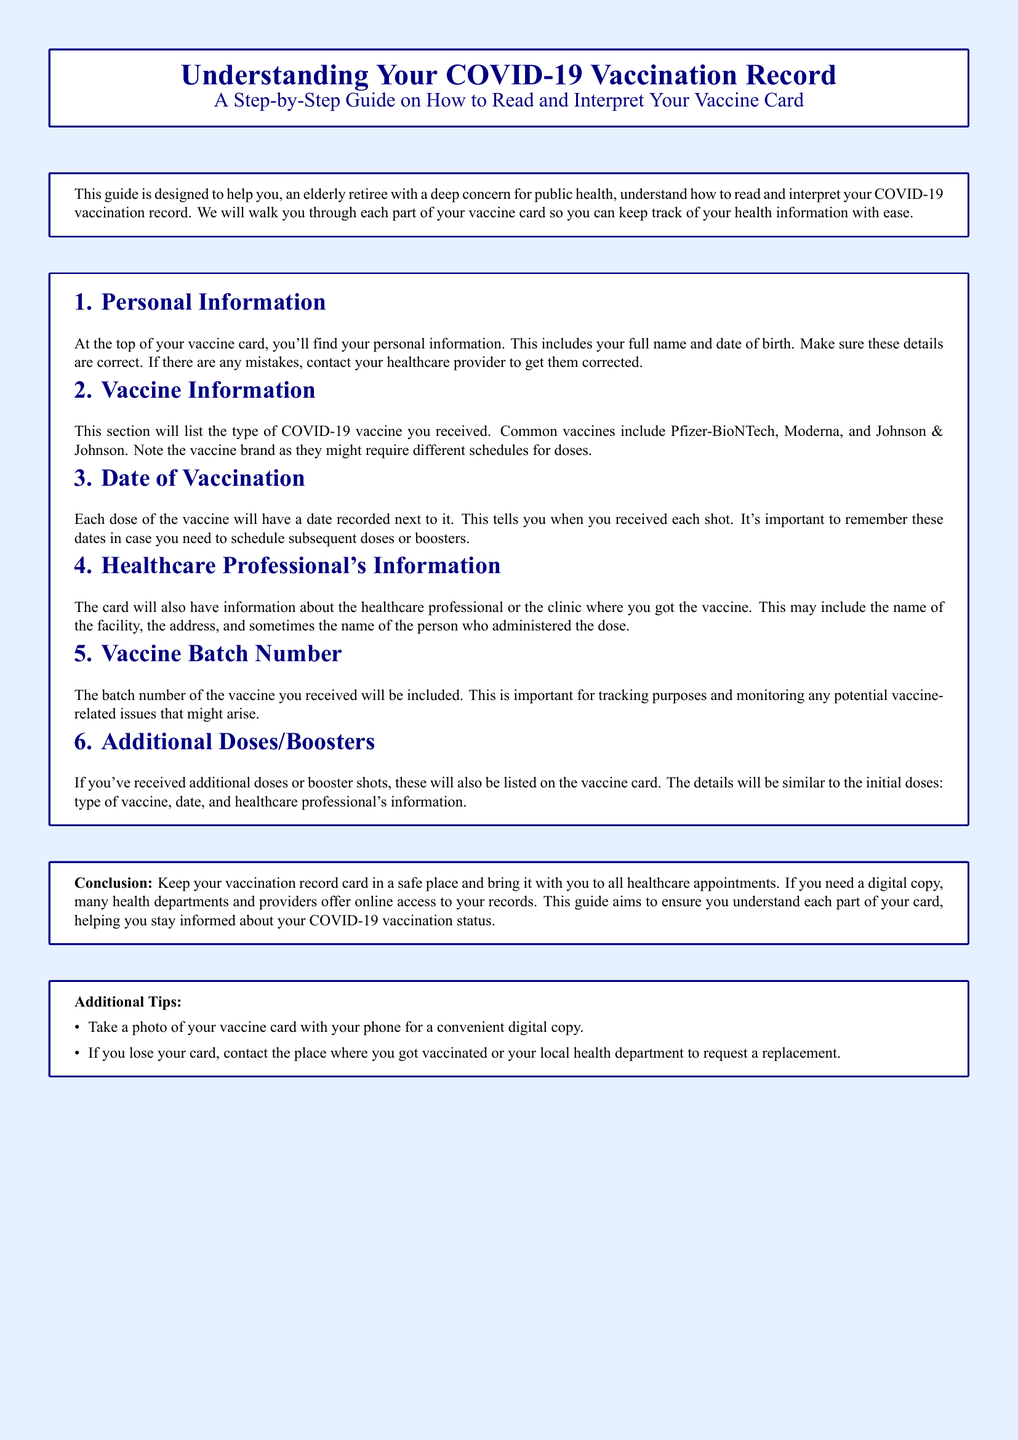what information is at the top of the vaccine card? The top of the vaccine card includes your full name and date of birth.
Answer: full name and date of birth what are the common vaccines listed in the document? The document mentions common vaccines including Pfizer-BioNTech, Moderna, and Johnson & Johnson.
Answer: Pfizer-BioNTech, Moderna, Johnson & Johnson what should you do if your personal information has mistakes? If there are mistakes in your personal information, you should contact your healthcare provider to get them corrected.
Answer: contact your healthcare provider what is included in the Healthcare Professional's Information section? This section may include the name of the facility, the address, and sometimes the name of the person who administered the dose.
Answer: facility name, address, administer's name what number is relevant for tracking purposes? The vaccine batch number is relevant for tracking purposes.
Answer: vaccine batch number how can you keep a digital copy of your vaccine card? You can take a photo of your vaccine card with your phone for a convenient digital copy.
Answer: take a photo with your phone what should you do if you lose your vaccine card? If you lose your card, contact the place where you got vaccinated or your local health department to request a replacement.
Answer: contact the vaccination site or local health department which section of the card lists additional doses? The section that lists additional doses or booster shots includes similar details as the initial doses.
Answer: Additional Doses/Boosters section 